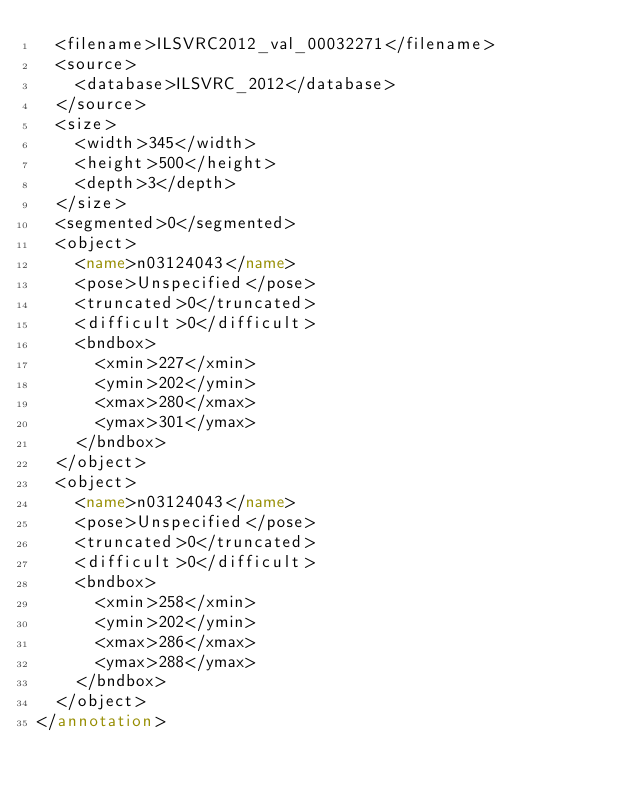Convert code to text. <code><loc_0><loc_0><loc_500><loc_500><_XML_>	<filename>ILSVRC2012_val_00032271</filename>
	<source>
		<database>ILSVRC_2012</database>
	</source>
	<size>
		<width>345</width>
		<height>500</height>
		<depth>3</depth>
	</size>
	<segmented>0</segmented>
	<object>
		<name>n03124043</name>
		<pose>Unspecified</pose>
		<truncated>0</truncated>
		<difficult>0</difficult>
		<bndbox>
			<xmin>227</xmin>
			<ymin>202</ymin>
			<xmax>280</xmax>
			<ymax>301</ymax>
		</bndbox>
	</object>
	<object>
		<name>n03124043</name>
		<pose>Unspecified</pose>
		<truncated>0</truncated>
		<difficult>0</difficult>
		<bndbox>
			<xmin>258</xmin>
			<ymin>202</ymin>
			<xmax>286</xmax>
			<ymax>288</ymax>
		</bndbox>
	</object>
</annotation></code> 